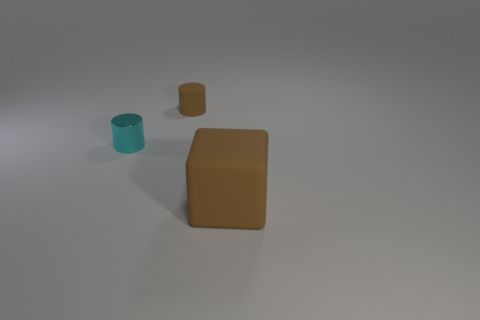Are there more small brown matte cylinders than brown rubber things?
Your response must be concise. No. There is a thing that is left of the matte thing left of the brown thing right of the small brown matte cylinder; what is its color?
Offer a very short reply. Cyan. There is a brown matte thing that is behind the big brown matte cube; is it the same shape as the big thing?
Keep it short and to the point. No. There is a thing that is the same size as the brown cylinder; what color is it?
Give a very brief answer. Cyan. How many small cyan things are there?
Provide a short and direct response. 1. Is the brown object in front of the cyan shiny object made of the same material as the tiny cyan thing?
Ensure brevity in your answer.  No. What material is the thing that is on the left side of the brown block and in front of the small brown rubber thing?
Provide a short and direct response. Metal. There is a rubber object that is the same color as the matte block; what size is it?
Provide a succinct answer. Small. What material is the object behind the small cyan object behind the brown cube made of?
Keep it short and to the point. Rubber. What is the size of the thing that is behind the tiny object to the left of the rubber thing behind the cyan metal object?
Your answer should be compact. Small. 